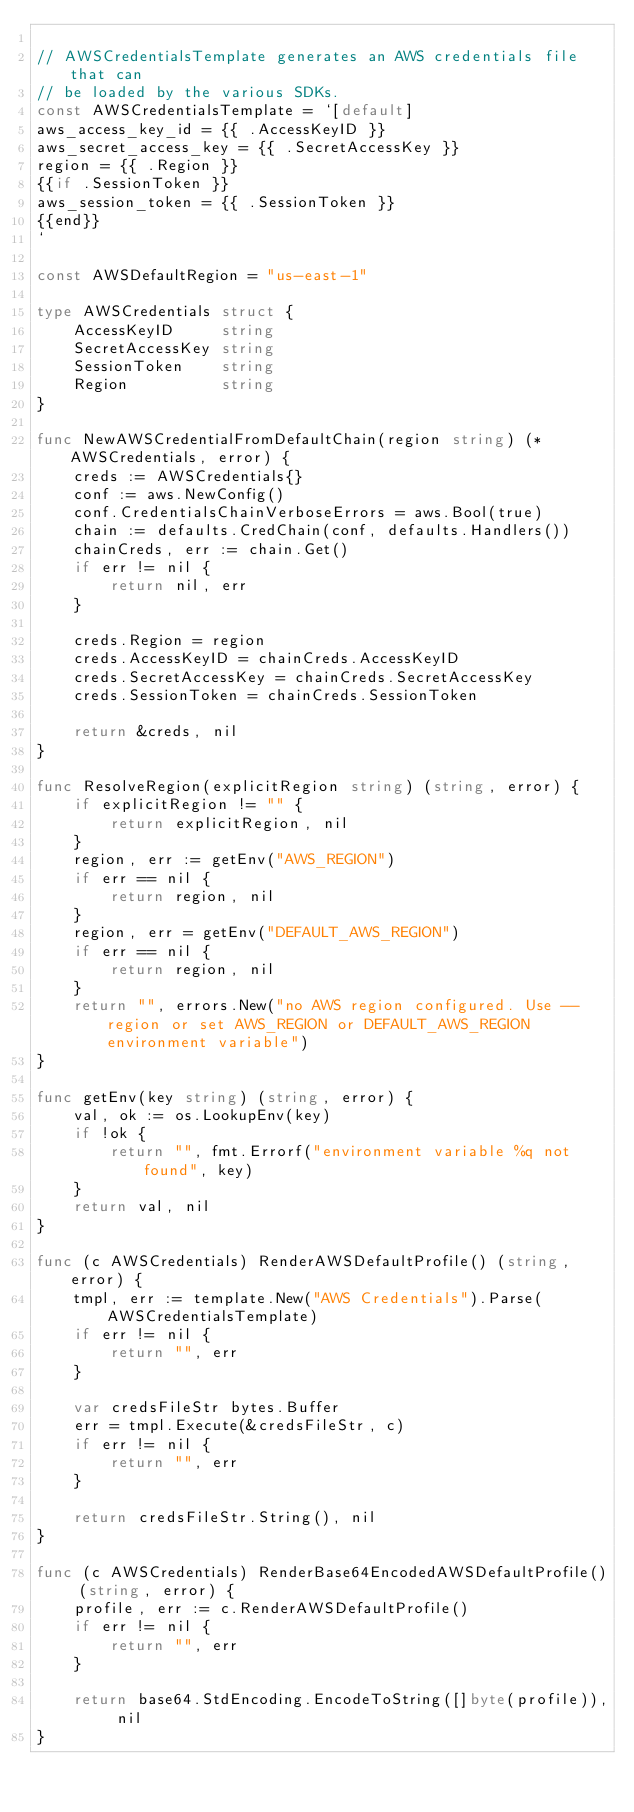<code> <loc_0><loc_0><loc_500><loc_500><_Go_>
// AWSCredentialsTemplate generates an AWS credentials file that can
// be loaded by the various SDKs.
const AWSCredentialsTemplate = `[default]
aws_access_key_id = {{ .AccessKeyID }}
aws_secret_access_key = {{ .SecretAccessKey }}
region = {{ .Region }}
{{if .SessionToken }}
aws_session_token = {{ .SessionToken }}
{{end}}
`

const AWSDefaultRegion = "us-east-1"

type AWSCredentials struct {
	AccessKeyID     string
	SecretAccessKey string
	SessionToken    string
	Region          string
}

func NewAWSCredentialFromDefaultChain(region string) (*AWSCredentials, error) {
	creds := AWSCredentials{}
	conf := aws.NewConfig()
	conf.CredentialsChainVerboseErrors = aws.Bool(true)
	chain := defaults.CredChain(conf, defaults.Handlers())
	chainCreds, err := chain.Get()
	if err != nil {
		return nil, err
	}

	creds.Region = region
	creds.AccessKeyID = chainCreds.AccessKeyID
	creds.SecretAccessKey = chainCreds.SecretAccessKey
	creds.SessionToken = chainCreds.SessionToken

	return &creds, nil
}

func ResolveRegion(explicitRegion string) (string, error) {
	if explicitRegion != "" {
		return explicitRegion, nil
	}
	region, err := getEnv("AWS_REGION")
	if err == nil {
		return region, nil
	}
	region, err = getEnv("DEFAULT_AWS_REGION")
	if err == nil {
		return region, nil
	}
	return "", errors.New("no AWS region configured. Use --region or set AWS_REGION or DEFAULT_AWS_REGION environment variable")
}

func getEnv(key string) (string, error) {
	val, ok := os.LookupEnv(key)
	if !ok {
		return "", fmt.Errorf("environment variable %q not found", key)
	}
	return val, nil
}

func (c AWSCredentials) RenderAWSDefaultProfile() (string, error) {
	tmpl, err := template.New("AWS Credentials").Parse(AWSCredentialsTemplate)
	if err != nil {
		return "", err
	}

	var credsFileStr bytes.Buffer
	err = tmpl.Execute(&credsFileStr, c)
	if err != nil {
		return "", err
	}

	return credsFileStr.String(), nil
}

func (c AWSCredentials) RenderBase64EncodedAWSDefaultProfile() (string, error) {
	profile, err := c.RenderAWSDefaultProfile()
	if err != nil {
		return "", err
	}

	return base64.StdEncoding.EncodeToString([]byte(profile)), nil
}
</code> 